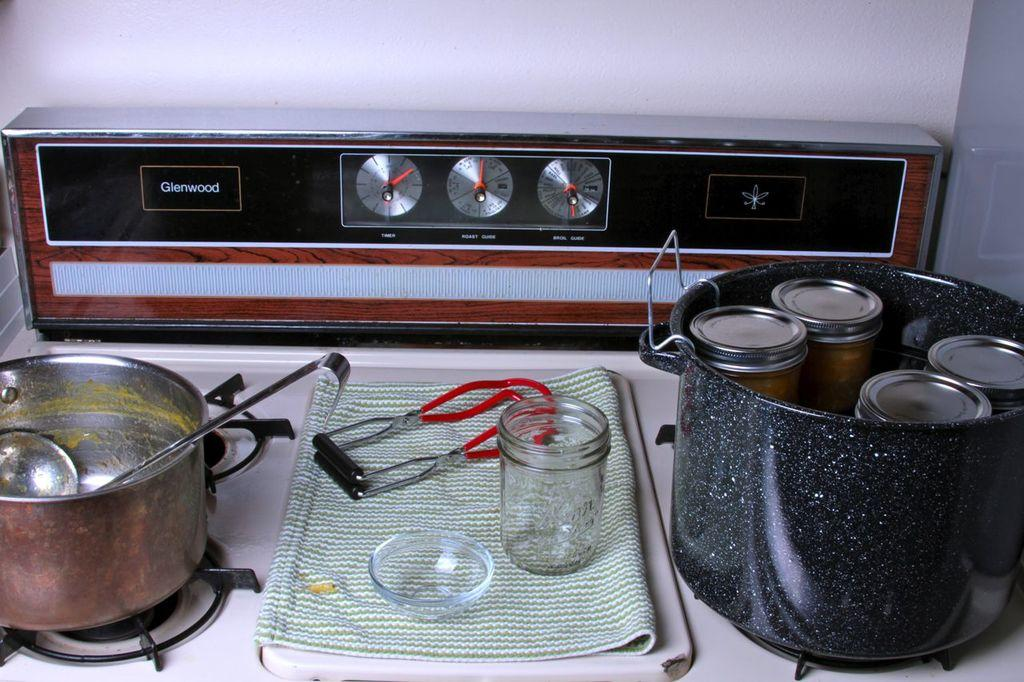Provide a one-sentence caption for the provided image. A canning supplies sit on the top of a Glenwood stove top. 